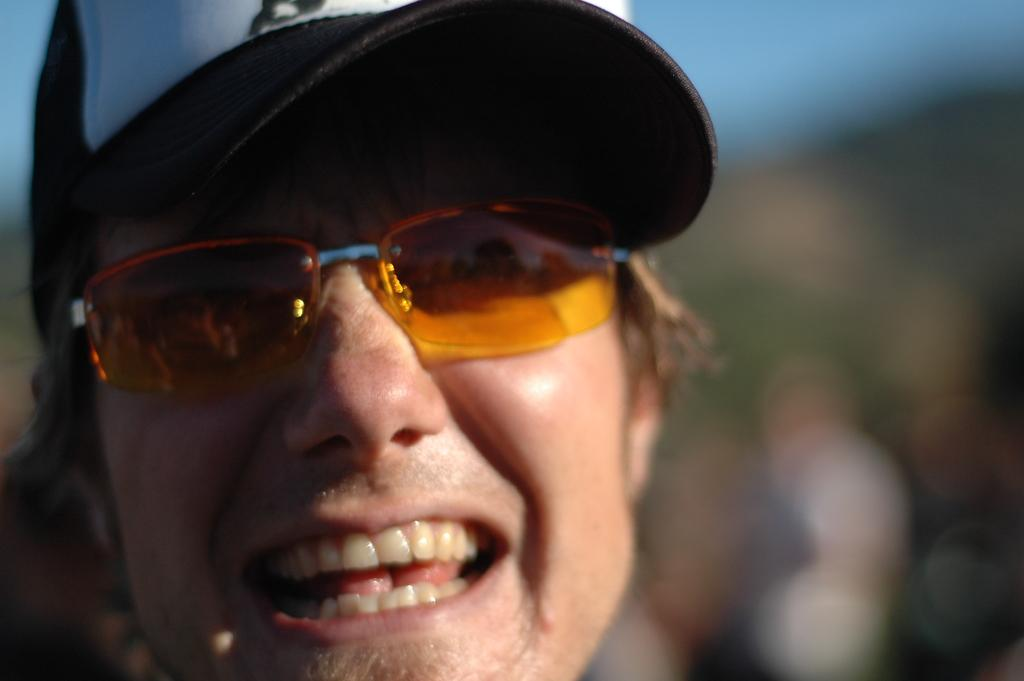What is the main subject of the image? The main subject of the image is a man's face. What is the man wearing on his head? The man is wearing a cap. What type of eyewear is the man wearing? The man is wearing shades. How would you describe the background of the image? The background of the image is blurred. What type of beef is the man cooking in the image? There is no beef or cooking activity present in the image; it only features a man's face with a cap and shades. Can you tell me the name of the man's parent in the image? There is no information about the man's parent in the image, as it only shows his face. 